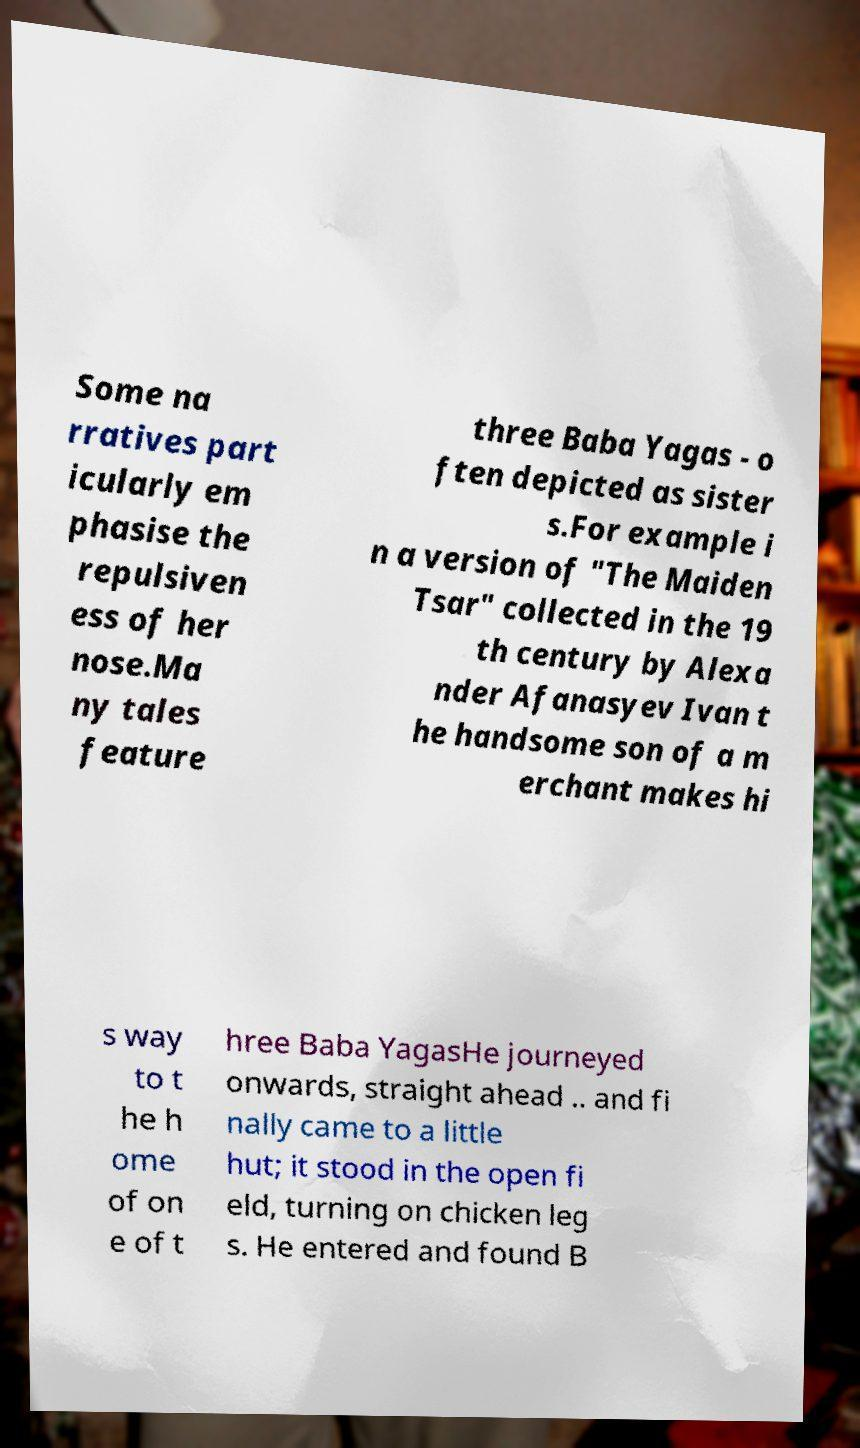Could you assist in decoding the text presented in this image and type it out clearly? Some na rratives part icularly em phasise the repulsiven ess of her nose.Ma ny tales feature three Baba Yagas - o ften depicted as sister s.For example i n a version of "The Maiden Tsar" collected in the 19 th century by Alexa nder Afanasyev Ivan t he handsome son of a m erchant makes hi s way to t he h ome of on e of t hree Baba YagasHe journeyed onwards, straight ahead .. and fi nally came to a little hut; it stood in the open fi eld, turning on chicken leg s. He entered and found B 